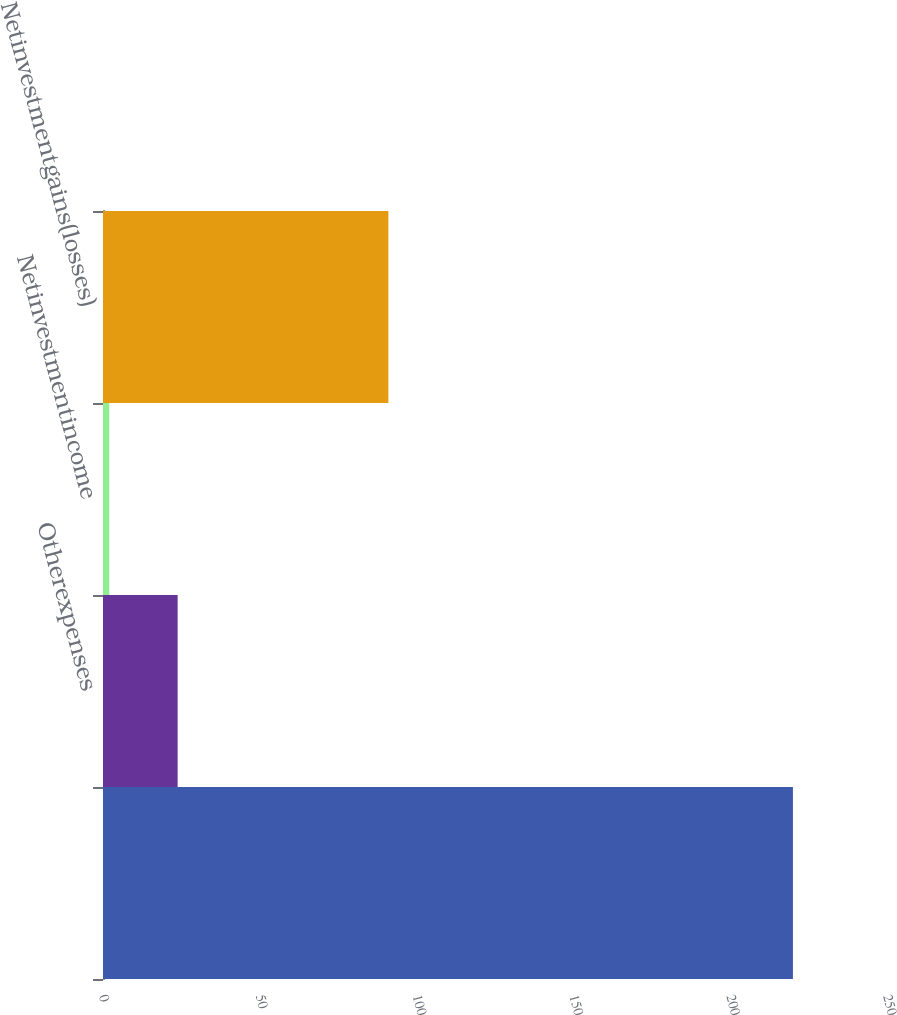Convert chart to OTSL. <chart><loc_0><loc_0><loc_500><loc_500><bar_chart><ecel><fcel>Otherexpenses<fcel>Netinvestmentincome<fcel>Netinvestmentgains(losses)<nl><fcel>220<fcel>23.8<fcel>2<fcel>91<nl></chart> 